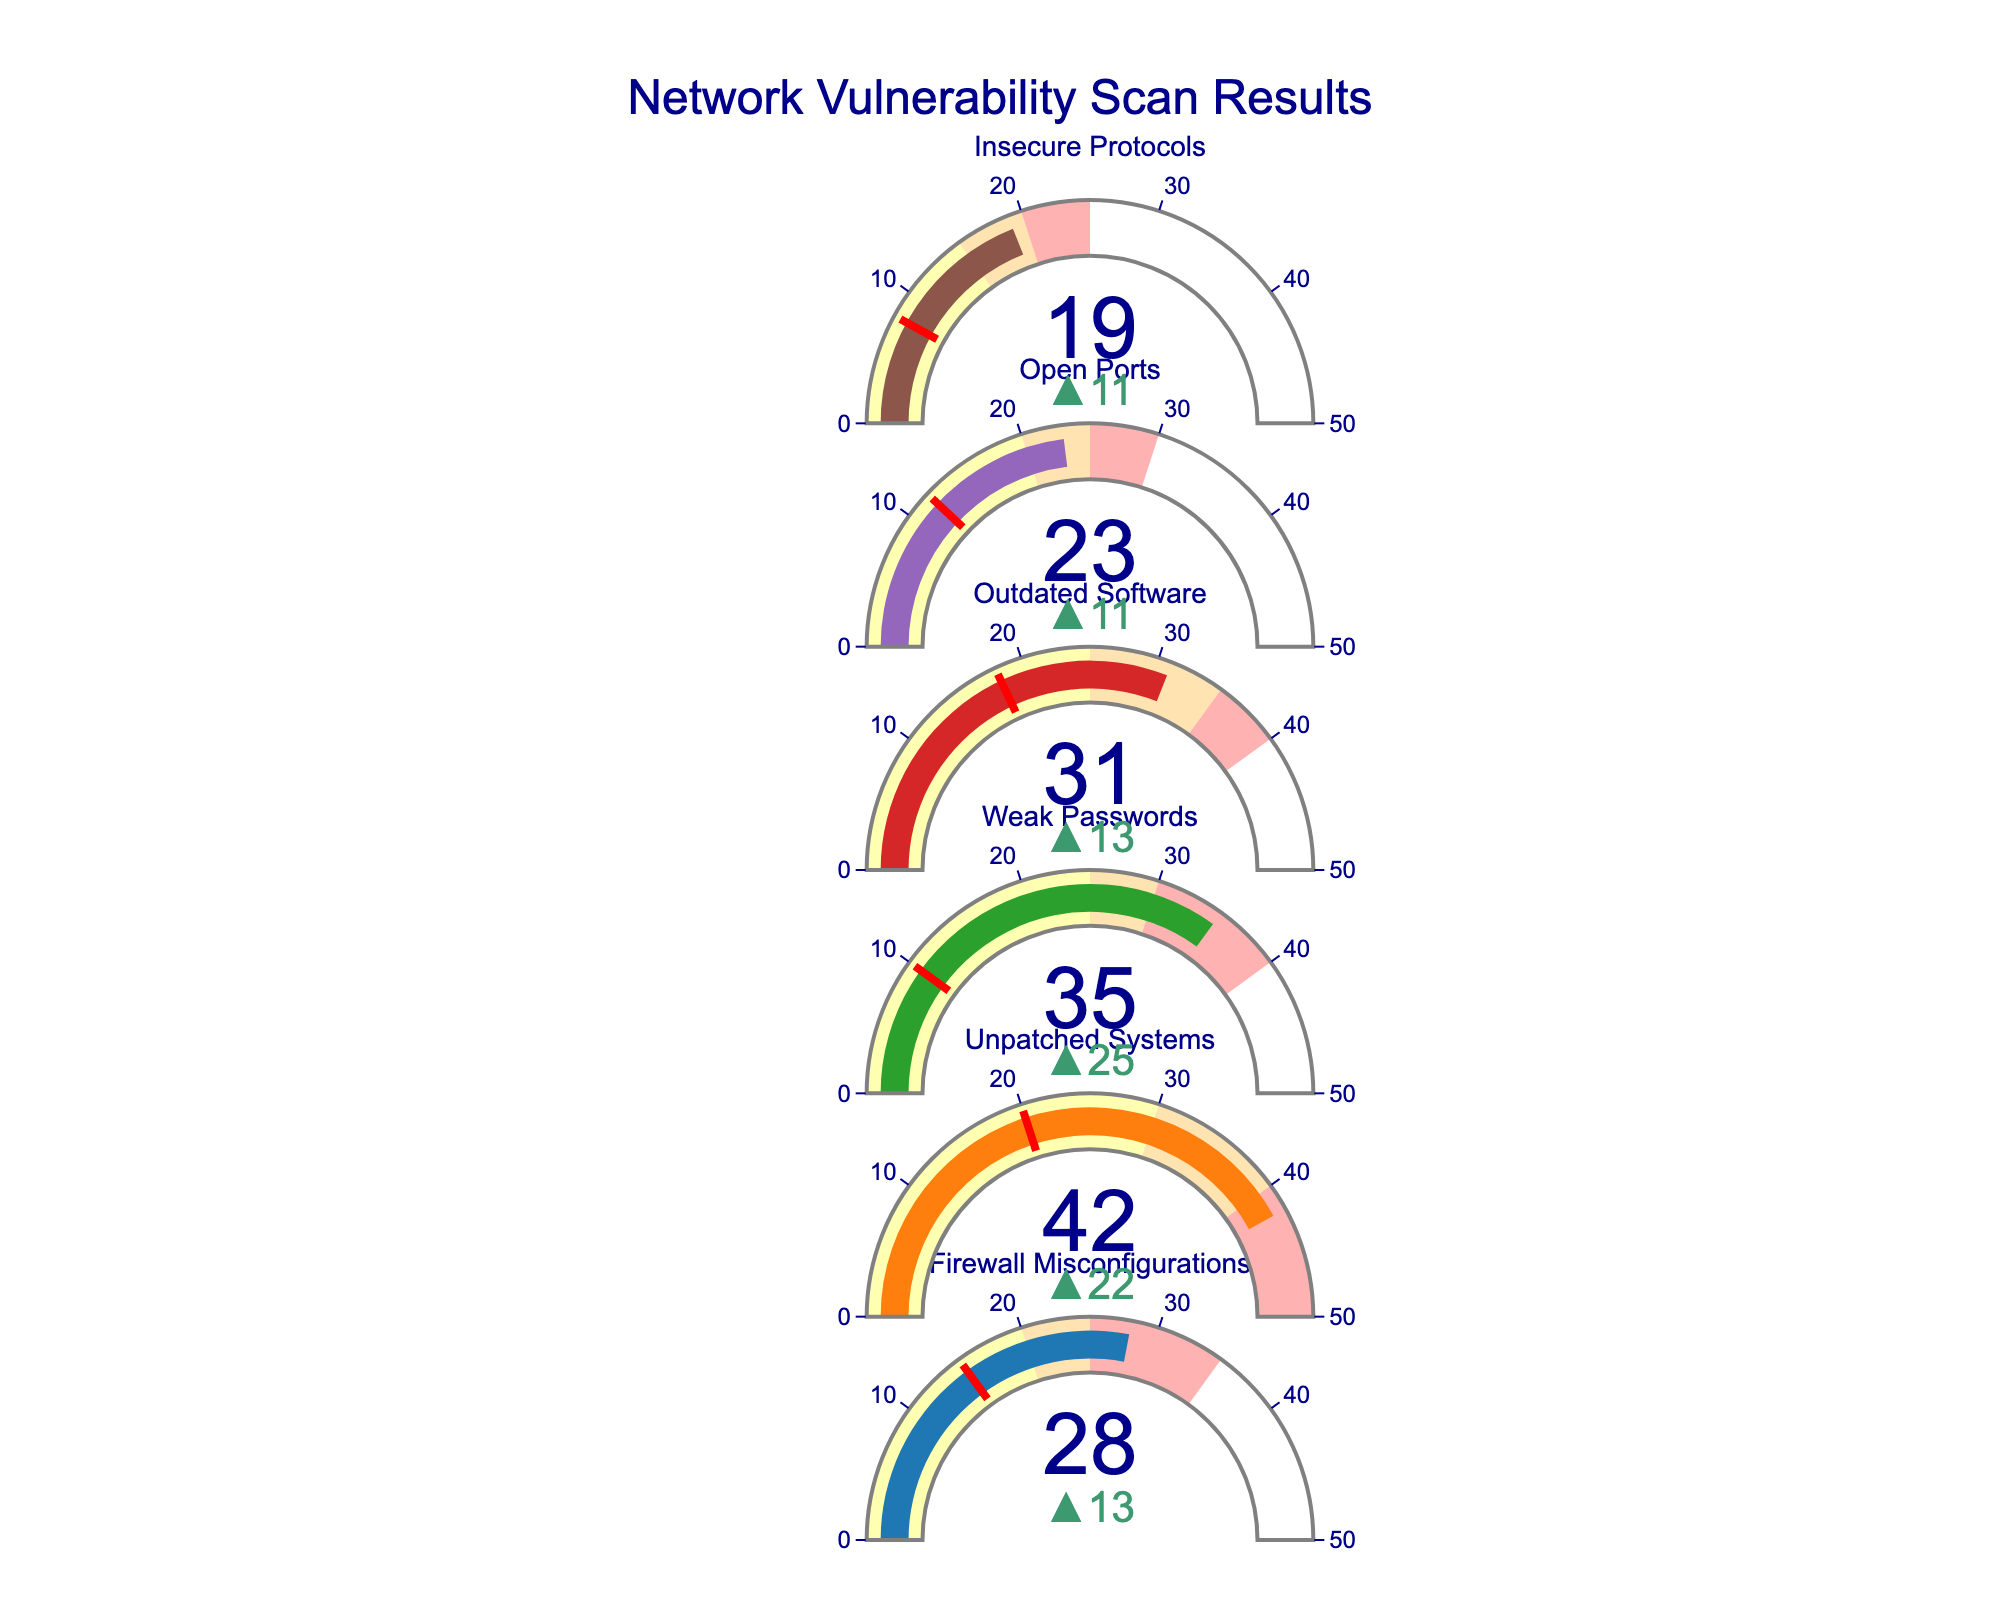How many categories are analyzed in the figure? There are six distinct rows/categories indicated in the figure, each associated with a different type of vulnerability.
Answer: Six What's the title of the figure? The title of the figure is placed at the top and reads "Network Vulnerability Scan Results."
Answer: Network Vulnerability Scan Results Which category has the highest actual value compared to its target? By examining the deltas (differences between actual values and targets), we see that 'Unpatched Systems' has an actual value of 42 and a target of 20, making it the highest deviation.
Answer: Unpatched Systems What is the critical value for 'Outdated Software'? Each category's critical value is indicated on the far-right side of the respective gauge. For 'Outdated Software,' the critical value is 40.
Answer: 40 Compare the actual values between 'Firewall Misconfigurations' and 'Weak Passwords.' Which one is higher? 'Firewall Misconfigurations' has an actual value of 28, whereas 'Weak Passwords' has an actual value of 35. Therefore, 'Weak Passwords' is higher.
Answer: Weak Passwords In which category is the difference between the actual value and the target closest? The 'Outdated Software' category has an actual value of 31 and a target of 18, making the difference 13, which is the closest among other categories.
Answer: Outdated Software Which category has the smallest margin between its high severity value and its medium severity value? By checking the steps in each gauge, 'Insecure Protocols' has a medium value of 15 and a high value of 20, which results in a margin of 5, the smallest among the categories.
Answer: Insecure Protocols Is there any category that meets or exceeds its target value based on the figure? By examining the deltas and thresholds, none of the actual values meet or exceed their respective target values, as all deltas indicate values below targets.
Answer: No What is the combined critical value of 'Weak Passwords' and 'Open Ports'? The critical value for 'Weak Passwords' is 40, and for 'Open Ports' is 30. Adding these gives 40 + 30 = 70.
Answer: 70 